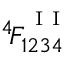Convert formula to latex. <formula><loc_0><loc_0><loc_500><loc_500>^ { 4 } \, F _ { 1 2 3 4 } ^ { ^ { I I } }</formula> 